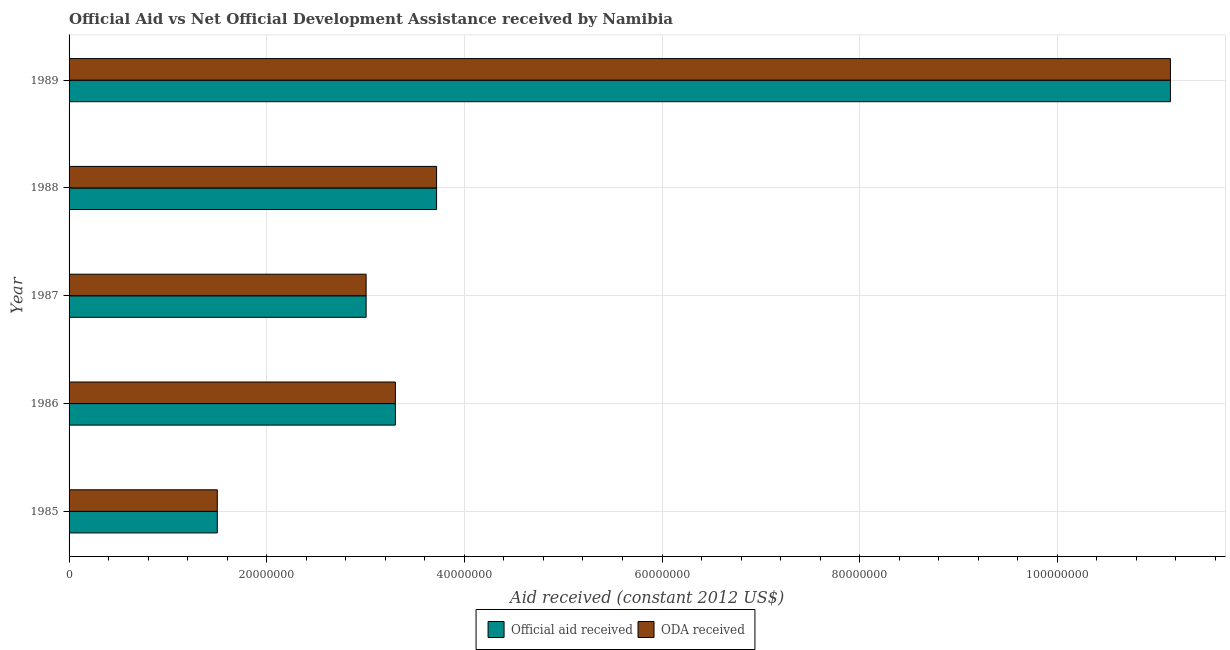How many groups of bars are there?
Your answer should be compact. 5. How many bars are there on the 4th tick from the top?
Provide a short and direct response. 2. How many bars are there on the 3rd tick from the bottom?
Offer a very short reply. 2. In how many cases, is the number of bars for a given year not equal to the number of legend labels?
Your answer should be very brief. 0. What is the official aid received in 1986?
Keep it short and to the point. 3.30e+07. Across all years, what is the maximum oda received?
Offer a terse response. 1.11e+08. Across all years, what is the minimum official aid received?
Make the answer very short. 1.50e+07. In which year was the official aid received maximum?
Your answer should be compact. 1989. What is the total official aid received in the graph?
Your answer should be very brief. 2.27e+08. What is the difference between the oda received in 1986 and that in 1988?
Your response must be concise. -4.17e+06. What is the difference between the oda received in 1985 and the official aid received in 1987?
Keep it short and to the point. -1.51e+07. What is the average oda received per year?
Keep it short and to the point. 4.53e+07. In the year 1988, what is the difference between the official aid received and oda received?
Offer a very short reply. 0. What is the ratio of the oda received in 1985 to that in 1986?
Offer a very short reply. 0.45. Is the oda received in 1985 less than that in 1986?
Offer a very short reply. Yes. What is the difference between the highest and the second highest official aid received?
Make the answer very short. 7.43e+07. What is the difference between the highest and the lowest oda received?
Offer a terse response. 9.64e+07. In how many years, is the official aid received greater than the average official aid received taken over all years?
Keep it short and to the point. 1. Is the sum of the oda received in 1985 and 1989 greater than the maximum official aid received across all years?
Keep it short and to the point. Yes. What does the 2nd bar from the top in 1985 represents?
Provide a succinct answer. Official aid received. What does the 1st bar from the bottom in 1988 represents?
Make the answer very short. Official aid received. How many bars are there?
Your response must be concise. 10. Are all the bars in the graph horizontal?
Ensure brevity in your answer.  Yes. How many years are there in the graph?
Give a very brief answer. 5. Does the graph contain any zero values?
Give a very brief answer. No. Does the graph contain grids?
Your answer should be compact. Yes. What is the title of the graph?
Keep it short and to the point. Official Aid vs Net Official Development Assistance received by Namibia . Does "Agricultural land" appear as one of the legend labels in the graph?
Your answer should be compact. No. What is the label or title of the X-axis?
Your answer should be very brief. Aid received (constant 2012 US$). What is the Aid received (constant 2012 US$) of Official aid received in 1985?
Make the answer very short. 1.50e+07. What is the Aid received (constant 2012 US$) in ODA received in 1985?
Make the answer very short. 1.50e+07. What is the Aid received (constant 2012 US$) in Official aid received in 1986?
Ensure brevity in your answer.  3.30e+07. What is the Aid received (constant 2012 US$) in ODA received in 1986?
Make the answer very short. 3.30e+07. What is the Aid received (constant 2012 US$) in Official aid received in 1987?
Ensure brevity in your answer.  3.01e+07. What is the Aid received (constant 2012 US$) of ODA received in 1987?
Offer a very short reply. 3.01e+07. What is the Aid received (constant 2012 US$) in Official aid received in 1988?
Keep it short and to the point. 3.72e+07. What is the Aid received (constant 2012 US$) of ODA received in 1988?
Provide a short and direct response. 3.72e+07. What is the Aid received (constant 2012 US$) of Official aid received in 1989?
Provide a short and direct response. 1.11e+08. What is the Aid received (constant 2012 US$) in ODA received in 1989?
Provide a succinct answer. 1.11e+08. Across all years, what is the maximum Aid received (constant 2012 US$) in Official aid received?
Offer a terse response. 1.11e+08. Across all years, what is the maximum Aid received (constant 2012 US$) in ODA received?
Keep it short and to the point. 1.11e+08. Across all years, what is the minimum Aid received (constant 2012 US$) in Official aid received?
Provide a succinct answer. 1.50e+07. Across all years, what is the minimum Aid received (constant 2012 US$) of ODA received?
Ensure brevity in your answer.  1.50e+07. What is the total Aid received (constant 2012 US$) of Official aid received in the graph?
Give a very brief answer. 2.27e+08. What is the total Aid received (constant 2012 US$) in ODA received in the graph?
Ensure brevity in your answer.  2.27e+08. What is the difference between the Aid received (constant 2012 US$) of Official aid received in 1985 and that in 1986?
Offer a very short reply. -1.80e+07. What is the difference between the Aid received (constant 2012 US$) in ODA received in 1985 and that in 1986?
Make the answer very short. -1.80e+07. What is the difference between the Aid received (constant 2012 US$) of Official aid received in 1985 and that in 1987?
Your answer should be compact. -1.51e+07. What is the difference between the Aid received (constant 2012 US$) in ODA received in 1985 and that in 1987?
Offer a very short reply. -1.51e+07. What is the difference between the Aid received (constant 2012 US$) in Official aid received in 1985 and that in 1988?
Provide a succinct answer. -2.22e+07. What is the difference between the Aid received (constant 2012 US$) of ODA received in 1985 and that in 1988?
Provide a succinct answer. -2.22e+07. What is the difference between the Aid received (constant 2012 US$) in Official aid received in 1985 and that in 1989?
Your answer should be very brief. -9.64e+07. What is the difference between the Aid received (constant 2012 US$) of ODA received in 1985 and that in 1989?
Give a very brief answer. -9.64e+07. What is the difference between the Aid received (constant 2012 US$) in Official aid received in 1986 and that in 1987?
Keep it short and to the point. 2.96e+06. What is the difference between the Aid received (constant 2012 US$) of ODA received in 1986 and that in 1987?
Keep it short and to the point. 2.96e+06. What is the difference between the Aid received (constant 2012 US$) of Official aid received in 1986 and that in 1988?
Offer a terse response. -4.17e+06. What is the difference between the Aid received (constant 2012 US$) in ODA received in 1986 and that in 1988?
Keep it short and to the point. -4.17e+06. What is the difference between the Aid received (constant 2012 US$) of Official aid received in 1986 and that in 1989?
Ensure brevity in your answer.  -7.84e+07. What is the difference between the Aid received (constant 2012 US$) of ODA received in 1986 and that in 1989?
Ensure brevity in your answer.  -7.84e+07. What is the difference between the Aid received (constant 2012 US$) in Official aid received in 1987 and that in 1988?
Make the answer very short. -7.13e+06. What is the difference between the Aid received (constant 2012 US$) in ODA received in 1987 and that in 1988?
Offer a terse response. -7.13e+06. What is the difference between the Aid received (constant 2012 US$) of Official aid received in 1987 and that in 1989?
Give a very brief answer. -8.14e+07. What is the difference between the Aid received (constant 2012 US$) of ODA received in 1987 and that in 1989?
Your response must be concise. -8.14e+07. What is the difference between the Aid received (constant 2012 US$) in Official aid received in 1988 and that in 1989?
Your answer should be very brief. -7.43e+07. What is the difference between the Aid received (constant 2012 US$) in ODA received in 1988 and that in 1989?
Offer a very short reply. -7.43e+07. What is the difference between the Aid received (constant 2012 US$) of Official aid received in 1985 and the Aid received (constant 2012 US$) of ODA received in 1986?
Your answer should be compact. -1.80e+07. What is the difference between the Aid received (constant 2012 US$) in Official aid received in 1985 and the Aid received (constant 2012 US$) in ODA received in 1987?
Make the answer very short. -1.51e+07. What is the difference between the Aid received (constant 2012 US$) of Official aid received in 1985 and the Aid received (constant 2012 US$) of ODA received in 1988?
Your answer should be very brief. -2.22e+07. What is the difference between the Aid received (constant 2012 US$) of Official aid received in 1985 and the Aid received (constant 2012 US$) of ODA received in 1989?
Give a very brief answer. -9.64e+07. What is the difference between the Aid received (constant 2012 US$) in Official aid received in 1986 and the Aid received (constant 2012 US$) in ODA received in 1987?
Your response must be concise. 2.96e+06. What is the difference between the Aid received (constant 2012 US$) in Official aid received in 1986 and the Aid received (constant 2012 US$) in ODA received in 1988?
Offer a very short reply. -4.17e+06. What is the difference between the Aid received (constant 2012 US$) in Official aid received in 1986 and the Aid received (constant 2012 US$) in ODA received in 1989?
Give a very brief answer. -7.84e+07. What is the difference between the Aid received (constant 2012 US$) in Official aid received in 1987 and the Aid received (constant 2012 US$) in ODA received in 1988?
Your answer should be very brief. -7.13e+06. What is the difference between the Aid received (constant 2012 US$) of Official aid received in 1987 and the Aid received (constant 2012 US$) of ODA received in 1989?
Keep it short and to the point. -8.14e+07. What is the difference between the Aid received (constant 2012 US$) of Official aid received in 1988 and the Aid received (constant 2012 US$) of ODA received in 1989?
Keep it short and to the point. -7.43e+07. What is the average Aid received (constant 2012 US$) of Official aid received per year?
Provide a succinct answer. 4.53e+07. What is the average Aid received (constant 2012 US$) in ODA received per year?
Keep it short and to the point. 4.53e+07. In the year 1986, what is the difference between the Aid received (constant 2012 US$) in Official aid received and Aid received (constant 2012 US$) in ODA received?
Make the answer very short. 0. In the year 1987, what is the difference between the Aid received (constant 2012 US$) in Official aid received and Aid received (constant 2012 US$) in ODA received?
Offer a very short reply. 0. In the year 1988, what is the difference between the Aid received (constant 2012 US$) of Official aid received and Aid received (constant 2012 US$) of ODA received?
Offer a terse response. 0. What is the ratio of the Aid received (constant 2012 US$) in Official aid received in 1985 to that in 1986?
Your response must be concise. 0.45. What is the ratio of the Aid received (constant 2012 US$) of ODA received in 1985 to that in 1986?
Your response must be concise. 0.45. What is the ratio of the Aid received (constant 2012 US$) in Official aid received in 1985 to that in 1987?
Provide a succinct answer. 0.5. What is the ratio of the Aid received (constant 2012 US$) of ODA received in 1985 to that in 1987?
Offer a very short reply. 0.5. What is the ratio of the Aid received (constant 2012 US$) in Official aid received in 1985 to that in 1988?
Offer a terse response. 0.4. What is the ratio of the Aid received (constant 2012 US$) in ODA received in 1985 to that in 1988?
Keep it short and to the point. 0.4. What is the ratio of the Aid received (constant 2012 US$) in Official aid received in 1985 to that in 1989?
Make the answer very short. 0.13. What is the ratio of the Aid received (constant 2012 US$) of ODA received in 1985 to that in 1989?
Your answer should be compact. 0.13. What is the ratio of the Aid received (constant 2012 US$) in Official aid received in 1986 to that in 1987?
Your response must be concise. 1.1. What is the ratio of the Aid received (constant 2012 US$) in ODA received in 1986 to that in 1987?
Ensure brevity in your answer.  1.1. What is the ratio of the Aid received (constant 2012 US$) in Official aid received in 1986 to that in 1988?
Your answer should be very brief. 0.89. What is the ratio of the Aid received (constant 2012 US$) of ODA received in 1986 to that in 1988?
Give a very brief answer. 0.89. What is the ratio of the Aid received (constant 2012 US$) in Official aid received in 1986 to that in 1989?
Make the answer very short. 0.3. What is the ratio of the Aid received (constant 2012 US$) of ODA received in 1986 to that in 1989?
Your answer should be compact. 0.3. What is the ratio of the Aid received (constant 2012 US$) in Official aid received in 1987 to that in 1988?
Make the answer very short. 0.81. What is the ratio of the Aid received (constant 2012 US$) in ODA received in 1987 to that in 1988?
Offer a very short reply. 0.81. What is the ratio of the Aid received (constant 2012 US$) in Official aid received in 1987 to that in 1989?
Provide a succinct answer. 0.27. What is the ratio of the Aid received (constant 2012 US$) in ODA received in 1987 to that in 1989?
Give a very brief answer. 0.27. What is the ratio of the Aid received (constant 2012 US$) of Official aid received in 1988 to that in 1989?
Provide a short and direct response. 0.33. What is the ratio of the Aid received (constant 2012 US$) of ODA received in 1988 to that in 1989?
Offer a very short reply. 0.33. What is the difference between the highest and the second highest Aid received (constant 2012 US$) of Official aid received?
Your answer should be very brief. 7.43e+07. What is the difference between the highest and the second highest Aid received (constant 2012 US$) of ODA received?
Provide a short and direct response. 7.43e+07. What is the difference between the highest and the lowest Aid received (constant 2012 US$) of Official aid received?
Provide a succinct answer. 9.64e+07. What is the difference between the highest and the lowest Aid received (constant 2012 US$) of ODA received?
Keep it short and to the point. 9.64e+07. 